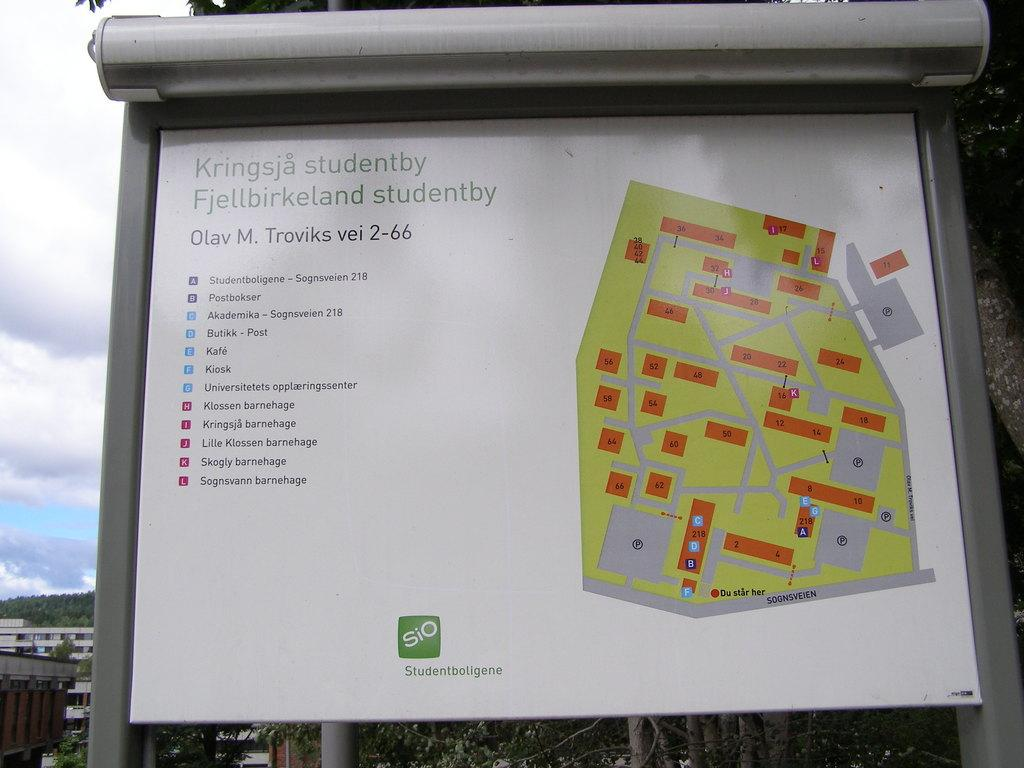<image>
Give a short and clear explanation of the subsequent image. a map of Kringsja has a list of places that are shown on the map 